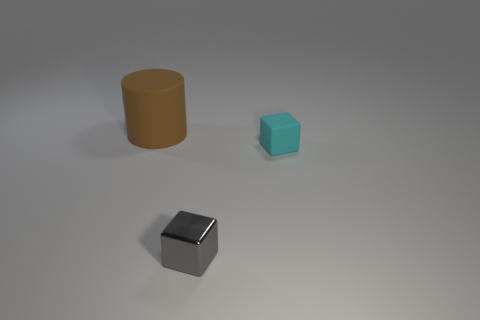Is there anything else that has the same size as the brown thing?
Keep it short and to the point. No. Are there any other things that have the same material as the gray block?
Your answer should be compact. No. Are there any other cyan things that have the same material as the tiny cyan thing?
Offer a terse response. No. There is a object to the right of the small gray block; is it the same shape as the small object that is in front of the rubber cube?
Keep it short and to the point. Yes. Are any metal things visible?
Keep it short and to the point. Yes. What is the color of the other object that is the same size as the cyan object?
Ensure brevity in your answer.  Gray. What number of small blue matte things are the same shape as the small gray shiny object?
Your answer should be very brief. 0. Is the cylinder behind the shiny object made of the same material as the tiny gray object?
Ensure brevity in your answer.  No. How many blocks are gray objects or tiny things?
Keep it short and to the point. 2. The matte object that is right of the small block left of the matte thing that is in front of the large brown cylinder is what shape?
Offer a very short reply. Cube. 